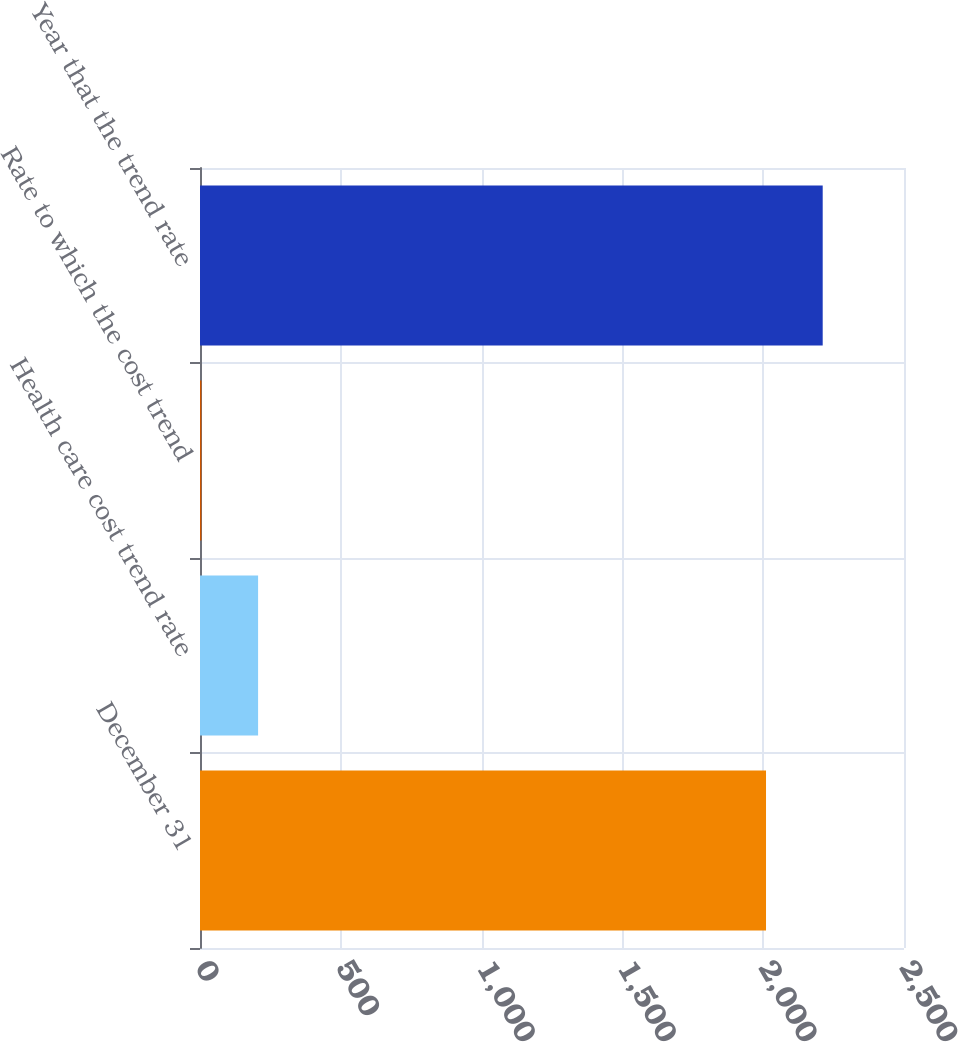Convert chart. <chart><loc_0><loc_0><loc_500><loc_500><bar_chart><fcel>December 31<fcel>Health care cost trend rate<fcel>Rate to which the cost trend<fcel>Year that the trend rate<nl><fcel>2010<fcel>206.3<fcel>5<fcel>2211.3<nl></chart> 